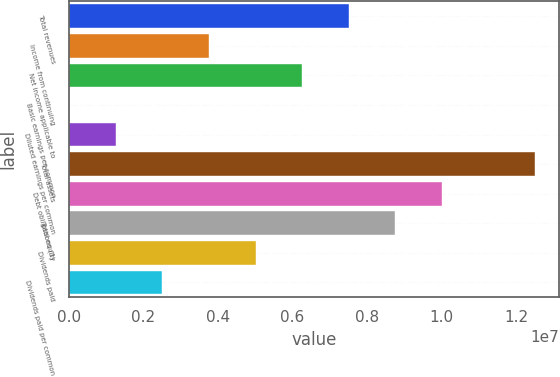Convert chart. <chart><loc_0><loc_0><loc_500><loc_500><bar_chart><fcel>Total revenues<fcel>Income from continuing<fcel>Net income applicable to<fcel>Basic earnings per common<fcel>Diluted earnings per common<fcel>Total assets<fcel>Debt obligations (3)<fcel>Total equity<fcel>Dividends paid<fcel>Dividends paid per common<nl><fcel>7.51306e+06<fcel>3.75653e+06<fcel>6.26089e+06<fcel>0.42<fcel>1.25218e+06<fcel>1.25218e+07<fcel>1.00174e+07<fcel>8.76524e+06<fcel>5.00871e+06<fcel>2.50435e+06<nl></chart> 